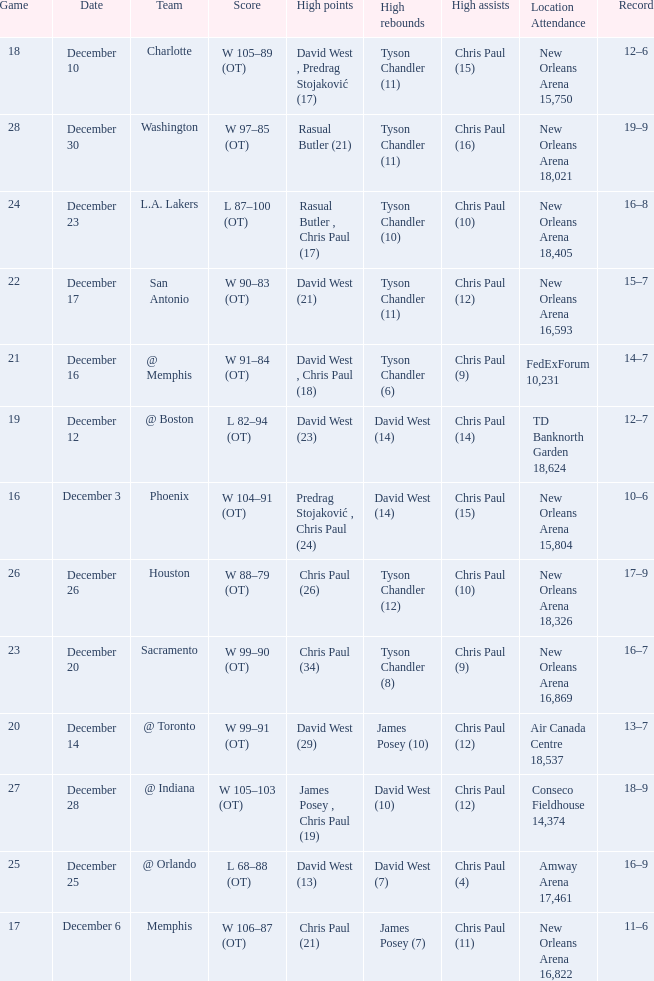What is Date, when Location Attendance is "TD Banknorth Garden 18,624"? December 12. 